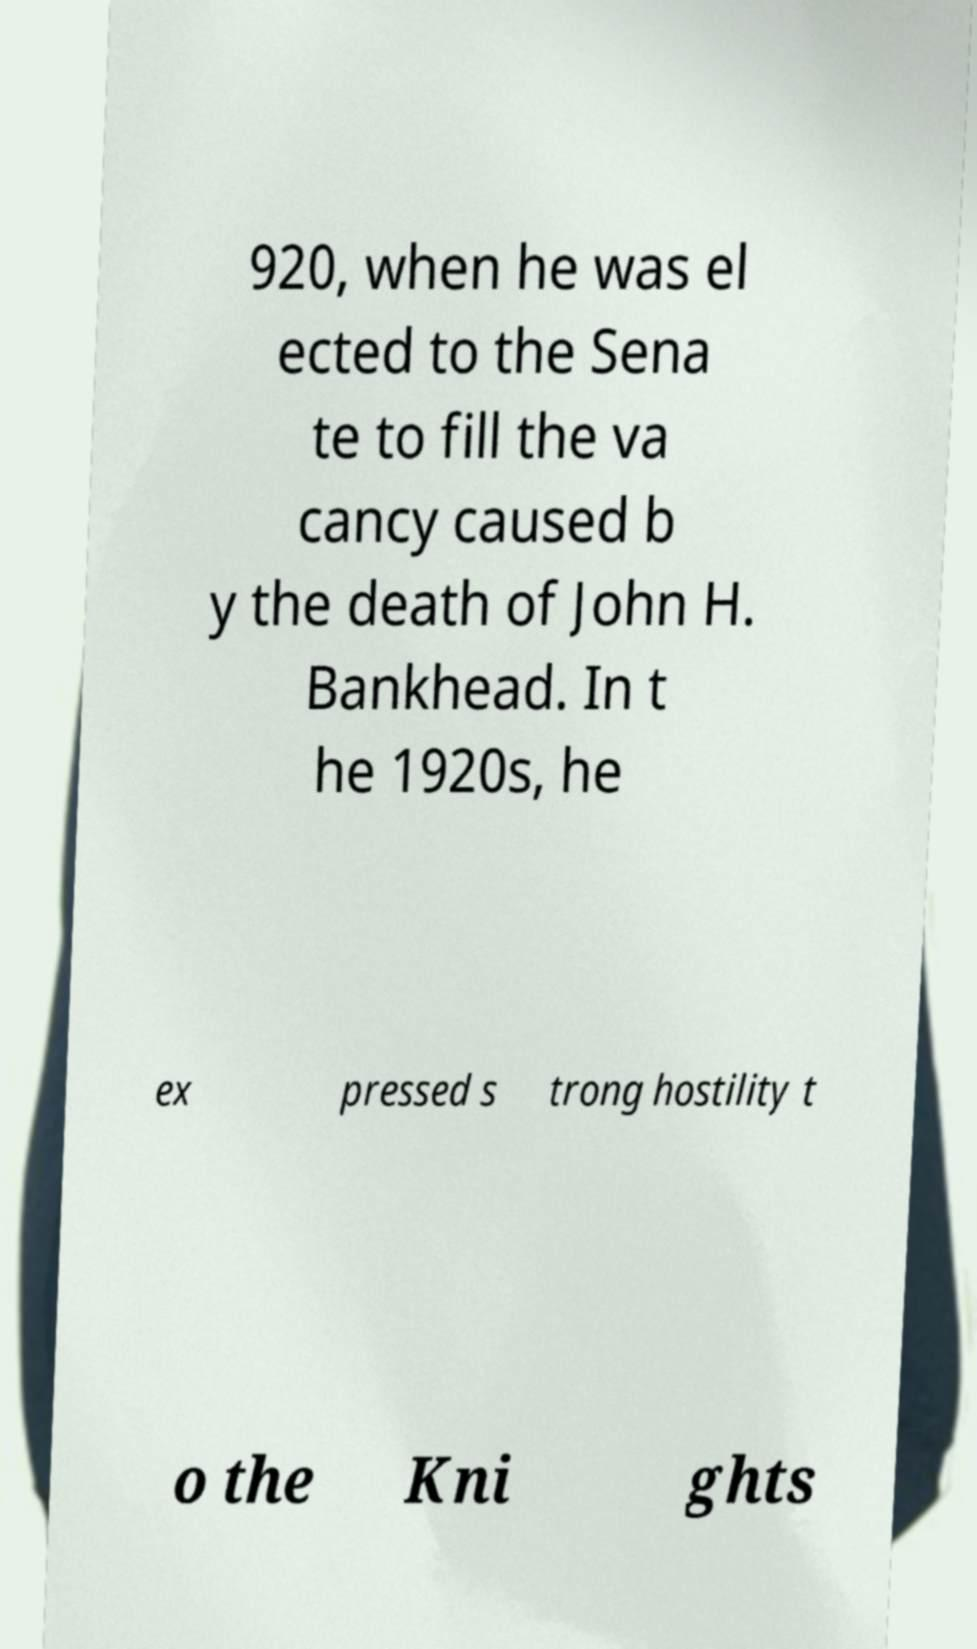Could you extract and type out the text from this image? 920, when he was el ected to the Sena te to fill the va cancy caused b y the death of John H. Bankhead. In t he 1920s, he ex pressed s trong hostility t o the Kni ghts 